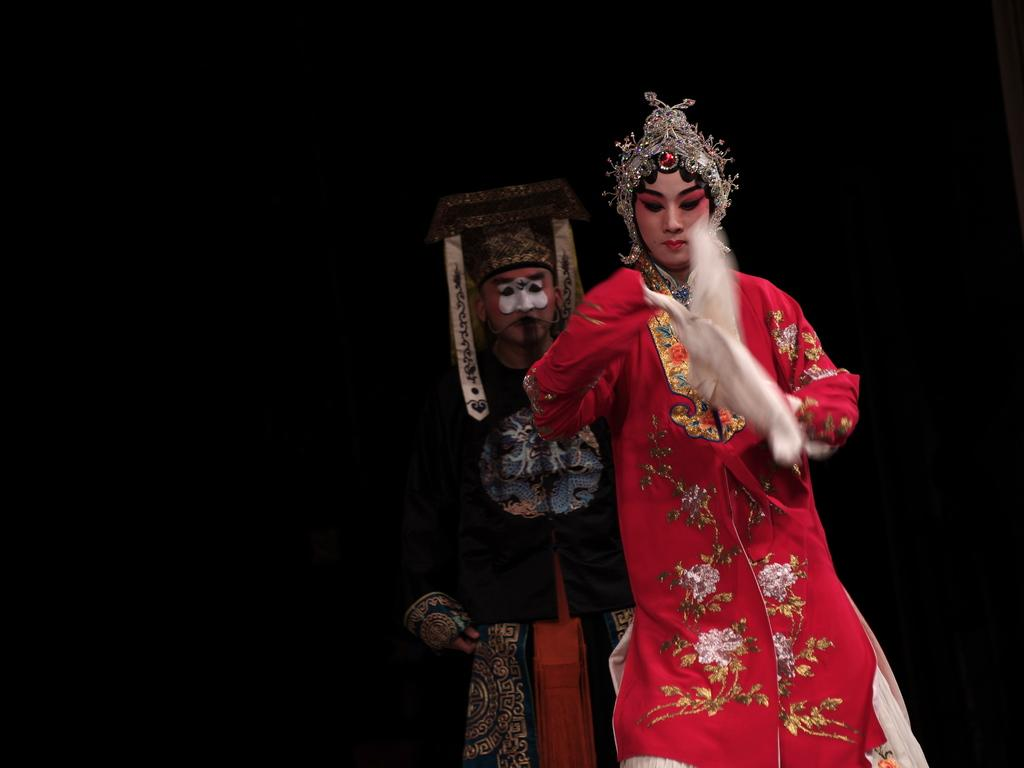How many people are in the image? There are two persons in the image. What are the persons wearing? The persons are wearing costumes. What color is the background of the image? The background of the image is black. Can you hear the wound in the image? There is no wound present in the image, and therefore it cannot be heard. 